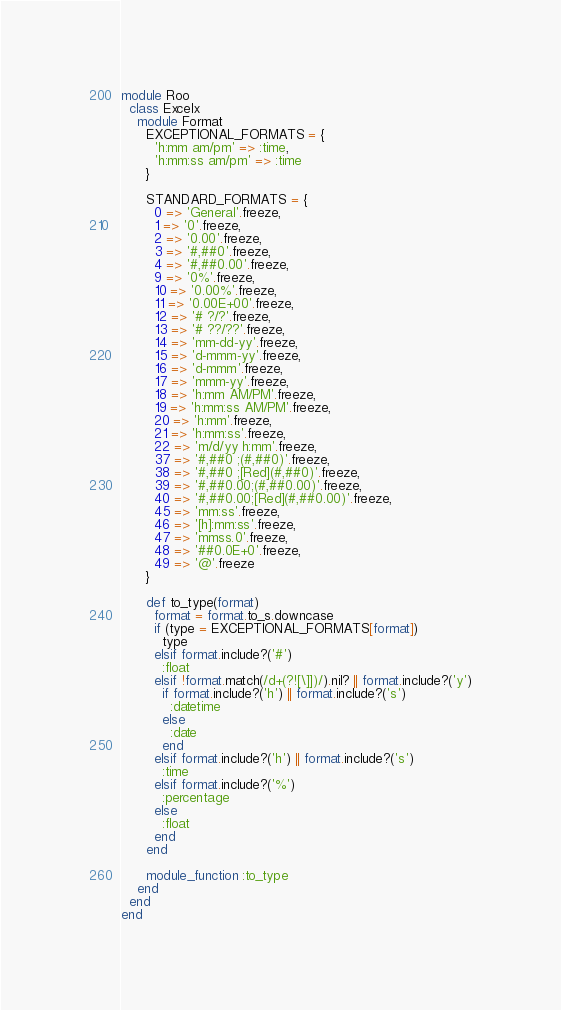Convert code to text. <code><loc_0><loc_0><loc_500><loc_500><_Ruby_>module Roo
  class Excelx
    module Format
      EXCEPTIONAL_FORMATS = {
        'h:mm am/pm' => :time,
        'h:mm:ss am/pm' => :time
      }

      STANDARD_FORMATS = {
        0 => 'General'.freeze,
        1 => '0'.freeze,
        2 => '0.00'.freeze,
        3 => '#,##0'.freeze,
        4 => '#,##0.00'.freeze,
        9 => '0%'.freeze,
        10 => '0.00%'.freeze,
        11 => '0.00E+00'.freeze,
        12 => '# ?/?'.freeze,
        13 => '# ??/??'.freeze,
        14 => 'mm-dd-yy'.freeze,
        15 => 'd-mmm-yy'.freeze,
        16 => 'd-mmm'.freeze,
        17 => 'mmm-yy'.freeze,
        18 => 'h:mm AM/PM'.freeze,
        19 => 'h:mm:ss AM/PM'.freeze,
        20 => 'h:mm'.freeze,
        21 => 'h:mm:ss'.freeze,
        22 => 'm/d/yy h:mm'.freeze,
        37 => '#,##0 ;(#,##0)'.freeze,
        38 => '#,##0 ;[Red](#,##0)'.freeze,
        39 => '#,##0.00;(#,##0.00)'.freeze,
        40 => '#,##0.00;[Red](#,##0.00)'.freeze,
        45 => 'mm:ss'.freeze,
        46 => '[h]:mm:ss'.freeze,
        47 => 'mmss.0'.freeze,
        48 => '##0.0E+0'.freeze,
        49 => '@'.freeze
      }

      def to_type(format)
        format = format.to_s.downcase
        if (type = EXCEPTIONAL_FORMATS[format])
          type
        elsif format.include?('#')
          :float
        elsif !format.match(/d+(?![\]])/).nil? || format.include?('y')
          if format.include?('h') || format.include?('s')
            :datetime
          else
            :date
          end
        elsif format.include?('h') || format.include?('s')
          :time
        elsif format.include?('%')
          :percentage
        else
          :float
        end
      end

      module_function :to_type
    end
  end
end
</code> 